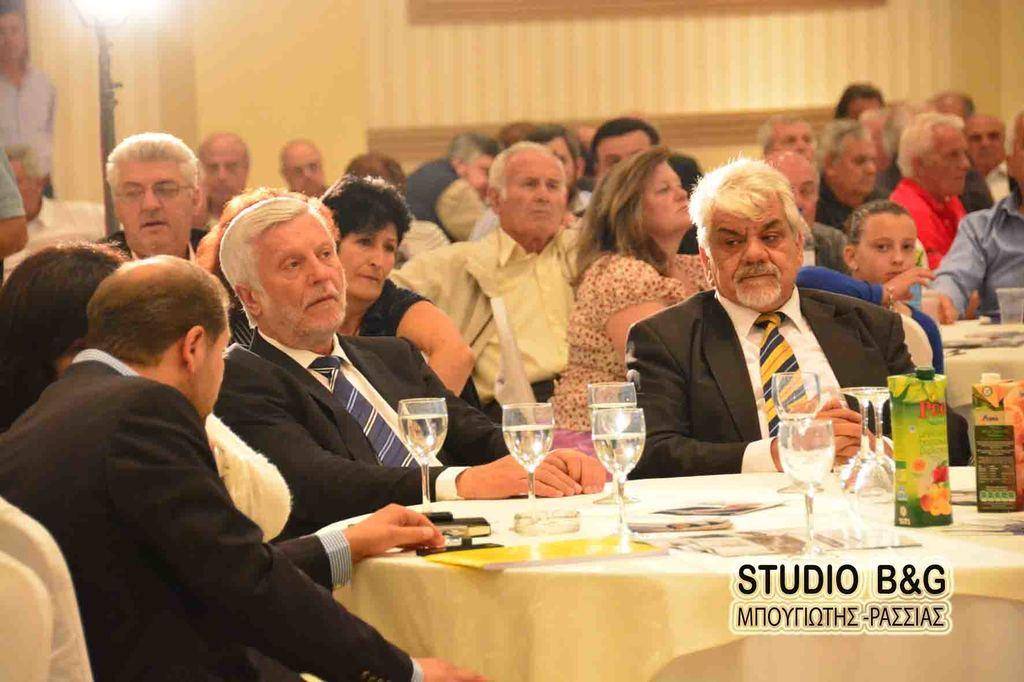What are the persons in the image doing? The persons in the image are sitting on chairs. What objects are placed in front of the chairs? Tables are placed in front of the chairs. What type of glasses can be seen on the tables? There are wine glasses on the tables. What items are present on the tables that might be used for communication? Printed cards are present on the tables. What type of beverage containers are visible on the tables? Juice cartons are visible on the tables. What type of error can be seen on the printed cards in the image? There is no mention of any errors on the printed cards in the image. What type of tools might a carpenter use in the image? There are no carpentry tools present in the image. 